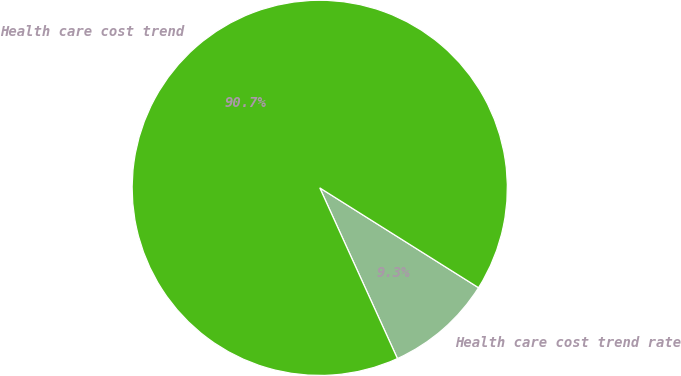Convert chart to OTSL. <chart><loc_0><loc_0><loc_500><loc_500><pie_chart><fcel>Health care cost trend rate<fcel>Health care cost trend<nl><fcel>9.27%<fcel>90.73%<nl></chart> 